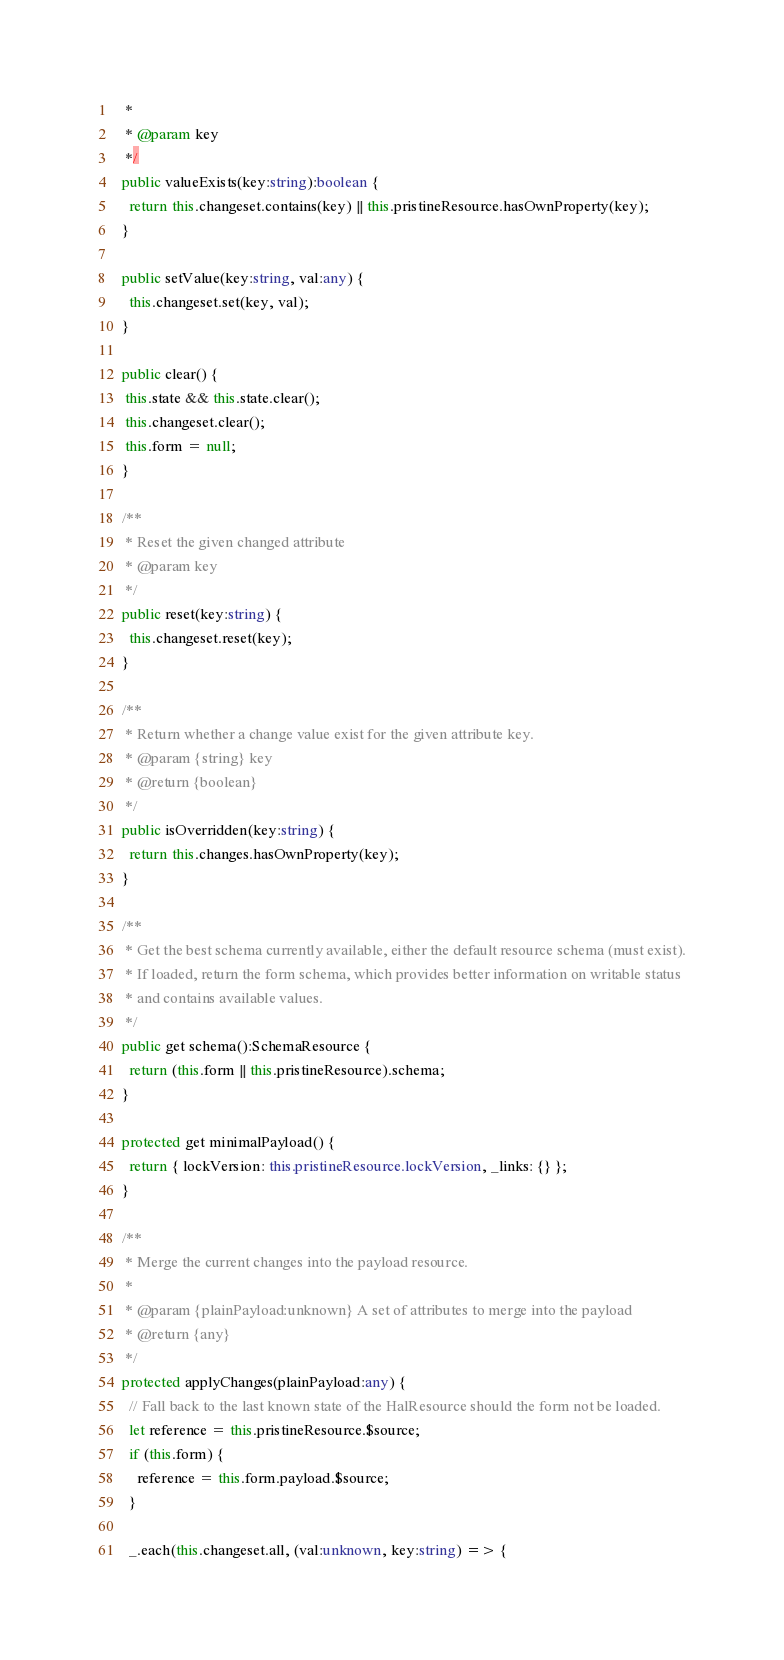Convert code to text. <code><loc_0><loc_0><loc_500><loc_500><_TypeScript_>   *
   * @param key
   */
  public valueExists(key:string):boolean {
    return this.changeset.contains(key) || this.pristineResource.hasOwnProperty(key);
  }

  public setValue(key:string, val:any) {
    this.changeset.set(key, val);
  }

  public clear() {
   this.state && this.state.clear();
   this.changeset.clear();
   this.form = null;
  }

  /**
   * Reset the given changed attribute
   * @param key
   */
  public reset(key:string) {
    this.changeset.reset(key);
  }

  /**
   * Return whether a change value exist for the given attribute key.
   * @param {string} key
   * @return {boolean}
   */
  public isOverridden(key:string) {
    return this.changes.hasOwnProperty(key);
  }

  /**
   * Get the best schema currently available, either the default resource schema (must exist).
   * If loaded, return the form schema, which provides better information on writable status
   * and contains available values.
   */
  public get schema():SchemaResource {
    return (this.form || this.pristineResource).schema;
  }

  protected get minimalPayload() {
    return { lockVersion: this.pristineResource.lockVersion, _links: {} };
  }

  /**
   * Merge the current changes into the payload resource.
   *
   * @param {plainPayload:unknown} A set of attributes to merge into the payload
   * @return {any}
   */
  protected applyChanges(plainPayload:any) {
    // Fall back to the last known state of the HalResource should the form not be loaded.
    let reference = this.pristineResource.$source;
    if (this.form) {
      reference = this.form.payload.$source;
    }

    _.each(this.changeset.all, (val:unknown, key:string) => {</code> 